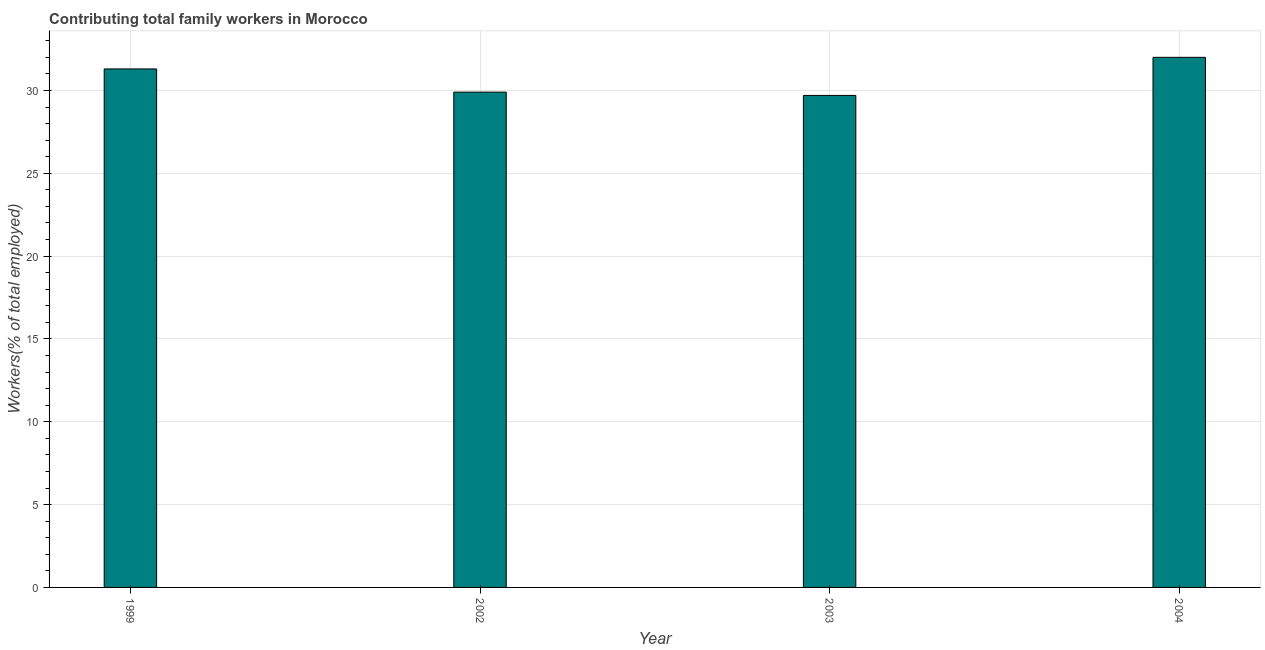Does the graph contain grids?
Your response must be concise. Yes. What is the title of the graph?
Make the answer very short. Contributing total family workers in Morocco. What is the label or title of the X-axis?
Make the answer very short. Year. What is the label or title of the Y-axis?
Offer a terse response. Workers(% of total employed). What is the contributing family workers in 2002?
Provide a short and direct response. 29.9. Across all years, what is the minimum contributing family workers?
Your answer should be compact. 29.7. What is the sum of the contributing family workers?
Offer a very short reply. 122.9. What is the difference between the contributing family workers in 2003 and 2004?
Give a very brief answer. -2.3. What is the average contributing family workers per year?
Keep it short and to the point. 30.73. What is the median contributing family workers?
Your answer should be compact. 30.6. What is the ratio of the contributing family workers in 2002 to that in 2004?
Ensure brevity in your answer.  0.93. Is the contributing family workers in 2002 less than that in 2003?
Provide a succinct answer. No. Is the difference between the contributing family workers in 1999 and 2004 greater than the difference between any two years?
Provide a short and direct response. No. What is the difference between the highest and the second highest contributing family workers?
Give a very brief answer. 0.7. Is the sum of the contributing family workers in 2002 and 2004 greater than the maximum contributing family workers across all years?
Make the answer very short. Yes. In how many years, is the contributing family workers greater than the average contributing family workers taken over all years?
Your response must be concise. 2. How many bars are there?
Your response must be concise. 4. Are the values on the major ticks of Y-axis written in scientific E-notation?
Make the answer very short. No. What is the Workers(% of total employed) in 1999?
Give a very brief answer. 31.3. What is the Workers(% of total employed) of 2002?
Your response must be concise. 29.9. What is the Workers(% of total employed) of 2003?
Offer a terse response. 29.7. What is the Workers(% of total employed) in 2004?
Your response must be concise. 32. What is the difference between the Workers(% of total employed) in 2003 and 2004?
Your answer should be very brief. -2.3. What is the ratio of the Workers(% of total employed) in 1999 to that in 2002?
Your answer should be very brief. 1.05. What is the ratio of the Workers(% of total employed) in 1999 to that in 2003?
Offer a very short reply. 1.05. What is the ratio of the Workers(% of total employed) in 2002 to that in 2003?
Offer a very short reply. 1.01. What is the ratio of the Workers(% of total employed) in 2002 to that in 2004?
Your response must be concise. 0.93. What is the ratio of the Workers(% of total employed) in 2003 to that in 2004?
Make the answer very short. 0.93. 